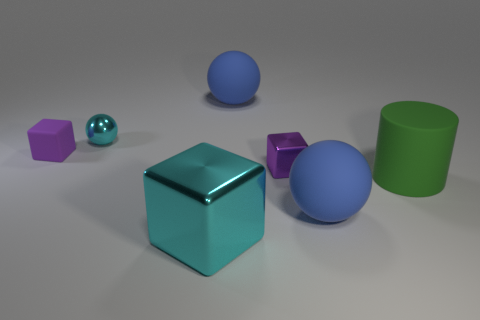There is a tiny thing that is the same color as the small shiny cube; what is it made of?
Make the answer very short. Rubber. There is a green matte cylinder; is its size the same as the cube behind the small purple metal object?
Offer a very short reply. No. What number of other objects are the same size as the purple matte object?
Keep it short and to the point. 2. What number of other things are there of the same color as the small sphere?
Provide a succinct answer. 1. How many other things are the same shape as the purple rubber thing?
Ensure brevity in your answer.  2. Is the size of the cyan metal block the same as the cyan shiny ball?
Your answer should be compact. No. Are any tiny cyan shiny cylinders visible?
Your answer should be compact. No. Is there a small object made of the same material as the big green object?
Keep it short and to the point. Yes. There is a ball that is the same size as the purple rubber block; what material is it?
Provide a succinct answer. Metal. What number of cyan metallic objects are the same shape as the green matte thing?
Ensure brevity in your answer.  0. 